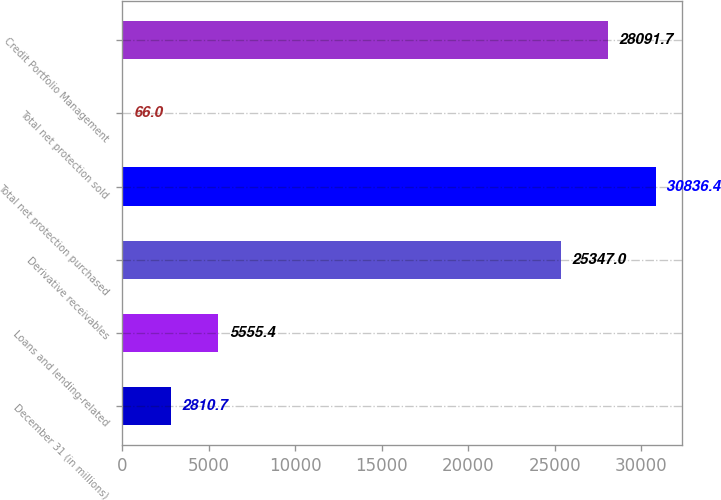Convert chart to OTSL. <chart><loc_0><loc_0><loc_500><loc_500><bar_chart><fcel>December 31 (in millions)<fcel>Loans and lending-related<fcel>Derivative receivables<fcel>Total net protection purchased<fcel>Total net protection sold<fcel>Credit Portfolio Management<nl><fcel>2810.7<fcel>5555.4<fcel>25347<fcel>30836.4<fcel>66<fcel>28091.7<nl></chart> 